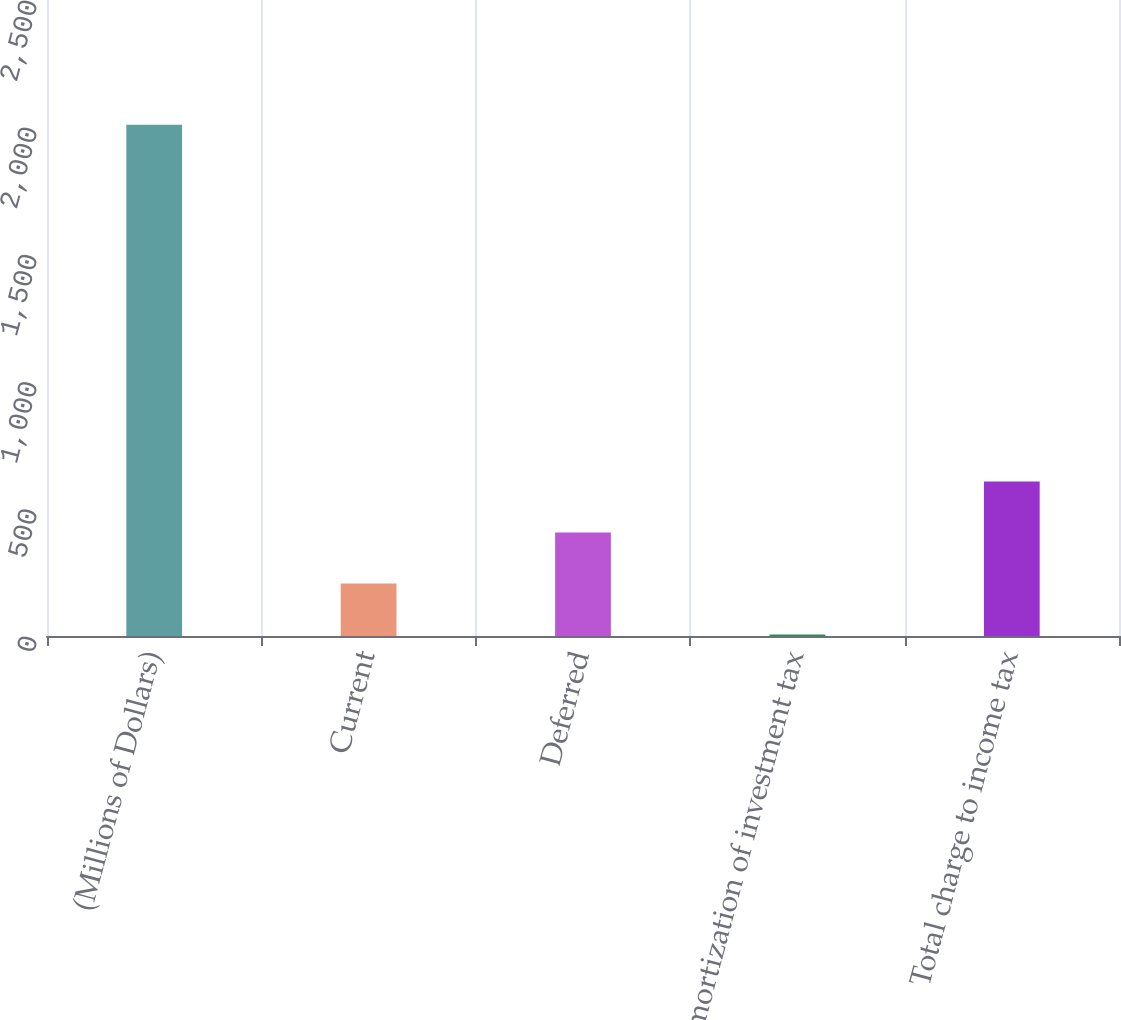Convert chart. <chart><loc_0><loc_0><loc_500><loc_500><bar_chart><fcel>(Millions of Dollars)<fcel>Current<fcel>Deferred<fcel>Amortization of investment tax<fcel>Total charge to income tax<nl><fcel>2010<fcel>206.4<fcel>406.8<fcel>6<fcel>607.2<nl></chart> 